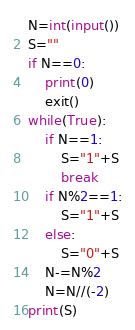Convert code to text. <code><loc_0><loc_0><loc_500><loc_500><_Python_>N=int(input())
S=""
if N==0:
    print(0)
    exit()
while(True):
    if N==1:
        S="1"+S
        break
    if N%2==1:
        S="1"+S
    else:
        S="0"+S
    N-=N%2
    N=N//(-2)
print(S)
</code> 